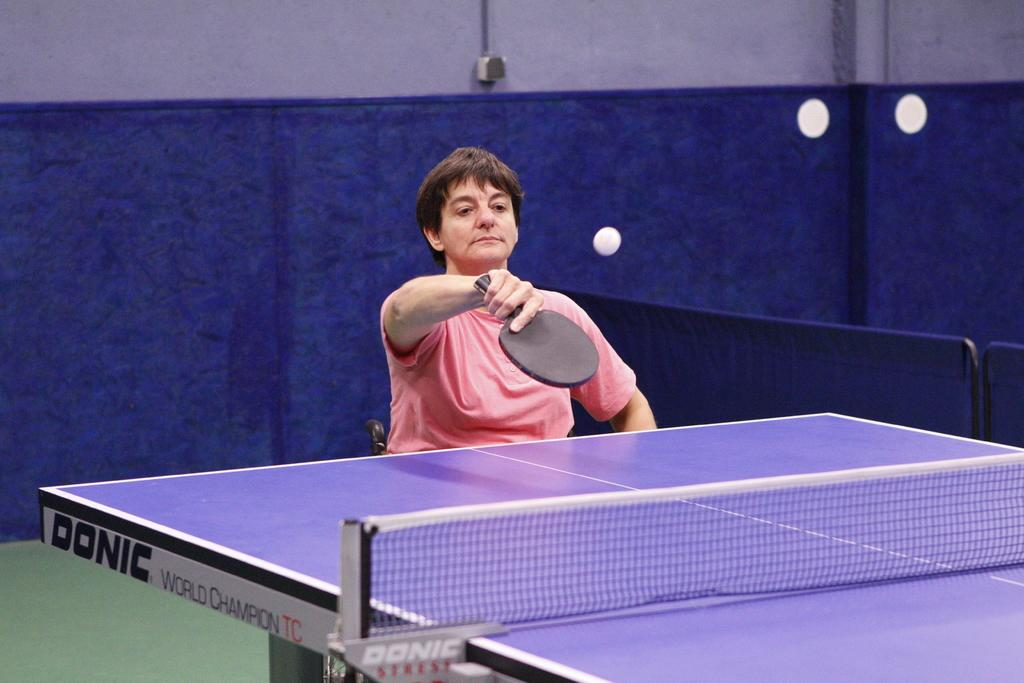Who is the main subject in the image? There is a person in the image. What is the person doing in the image? The person is playing table tennis. What type of bushes can be seen in the background of the image? There is no background or bushes visible in the image; it only shows a person playing table tennis. 